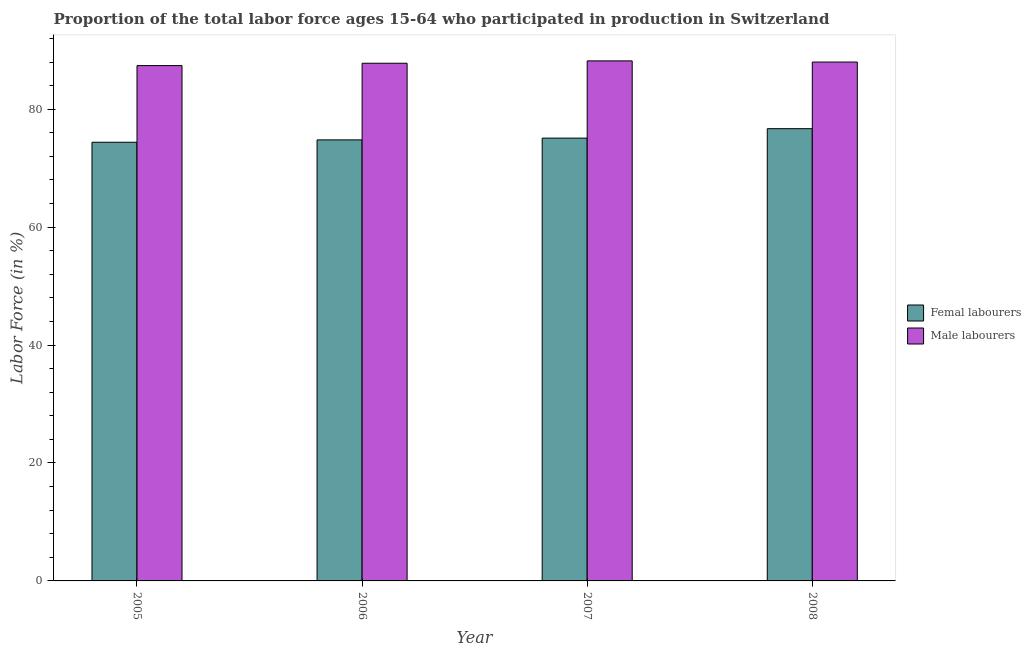How many bars are there on the 2nd tick from the right?
Provide a short and direct response. 2. What is the percentage of female labor force in 2005?
Provide a short and direct response. 74.4. Across all years, what is the maximum percentage of female labor force?
Keep it short and to the point. 76.7. Across all years, what is the minimum percentage of male labour force?
Provide a short and direct response. 87.4. In which year was the percentage of male labour force minimum?
Make the answer very short. 2005. What is the total percentage of female labor force in the graph?
Your answer should be very brief. 301. What is the difference between the percentage of female labor force in 2005 and that in 2007?
Provide a succinct answer. -0.7. What is the difference between the percentage of female labor force in 2005 and the percentage of male labour force in 2007?
Provide a succinct answer. -0.7. What is the average percentage of female labor force per year?
Keep it short and to the point. 75.25. In how many years, is the percentage of female labor force greater than 76 %?
Offer a terse response. 1. What is the ratio of the percentage of female labor force in 2007 to that in 2008?
Your answer should be compact. 0.98. What is the difference between the highest and the second highest percentage of male labour force?
Your answer should be compact. 0.2. What is the difference between the highest and the lowest percentage of male labour force?
Offer a terse response. 0.8. In how many years, is the percentage of male labour force greater than the average percentage of male labour force taken over all years?
Provide a short and direct response. 2. What does the 2nd bar from the left in 2005 represents?
Offer a very short reply. Male labourers. What does the 1st bar from the right in 2006 represents?
Offer a terse response. Male labourers. How many bars are there?
Your answer should be compact. 8. What is the difference between two consecutive major ticks on the Y-axis?
Give a very brief answer. 20. How many legend labels are there?
Provide a succinct answer. 2. What is the title of the graph?
Make the answer very short. Proportion of the total labor force ages 15-64 who participated in production in Switzerland. Does "By country of origin" appear as one of the legend labels in the graph?
Make the answer very short. No. What is the label or title of the X-axis?
Provide a short and direct response. Year. What is the label or title of the Y-axis?
Give a very brief answer. Labor Force (in %). What is the Labor Force (in %) of Femal labourers in 2005?
Give a very brief answer. 74.4. What is the Labor Force (in %) of Male labourers in 2005?
Offer a very short reply. 87.4. What is the Labor Force (in %) in Femal labourers in 2006?
Give a very brief answer. 74.8. What is the Labor Force (in %) in Male labourers in 2006?
Provide a short and direct response. 87.8. What is the Labor Force (in %) of Femal labourers in 2007?
Your answer should be compact. 75.1. What is the Labor Force (in %) in Male labourers in 2007?
Offer a very short reply. 88.2. What is the Labor Force (in %) of Femal labourers in 2008?
Ensure brevity in your answer.  76.7. What is the Labor Force (in %) of Male labourers in 2008?
Ensure brevity in your answer.  88. Across all years, what is the maximum Labor Force (in %) in Femal labourers?
Your response must be concise. 76.7. Across all years, what is the maximum Labor Force (in %) of Male labourers?
Your answer should be compact. 88.2. Across all years, what is the minimum Labor Force (in %) in Femal labourers?
Keep it short and to the point. 74.4. Across all years, what is the minimum Labor Force (in %) of Male labourers?
Ensure brevity in your answer.  87.4. What is the total Labor Force (in %) in Femal labourers in the graph?
Offer a very short reply. 301. What is the total Labor Force (in %) in Male labourers in the graph?
Offer a very short reply. 351.4. What is the difference between the Labor Force (in %) of Femal labourers in 2005 and that in 2007?
Provide a succinct answer. -0.7. What is the difference between the Labor Force (in %) in Male labourers in 2005 and that in 2007?
Your answer should be compact. -0.8. What is the difference between the Labor Force (in %) of Femal labourers in 2005 and that in 2008?
Offer a terse response. -2.3. What is the difference between the Labor Force (in %) in Femal labourers in 2006 and that in 2007?
Keep it short and to the point. -0.3. What is the difference between the Labor Force (in %) in Male labourers in 2006 and that in 2007?
Give a very brief answer. -0.4. What is the difference between the Labor Force (in %) in Male labourers in 2006 and that in 2008?
Your answer should be very brief. -0.2. What is the difference between the Labor Force (in %) of Femal labourers in 2007 and that in 2008?
Offer a terse response. -1.6. What is the difference between the Labor Force (in %) in Male labourers in 2007 and that in 2008?
Give a very brief answer. 0.2. What is the difference between the Labor Force (in %) of Femal labourers in 2005 and the Labor Force (in %) of Male labourers in 2006?
Your answer should be compact. -13.4. What is the difference between the Labor Force (in %) in Femal labourers in 2005 and the Labor Force (in %) in Male labourers in 2008?
Keep it short and to the point. -13.6. What is the difference between the Labor Force (in %) in Femal labourers in 2006 and the Labor Force (in %) in Male labourers in 2008?
Your answer should be compact. -13.2. What is the average Labor Force (in %) of Femal labourers per year?
Give a very brief answer. 75.25. What is the average Labor Force (in %) of Male labourers per year?
Offer a very short reply. 87.85. What is the ratio of the Labor Force (in %) of Femal labourers in 2005 to that in 2006?
Keep it short and to the point. 0.99. What is the ratio of the Labor Force (in %) in Femal labourers in 2005 to that in 2007?
Give a very brief answer. 0.99. What is the ratio of the Labor Force (in %) in Male labourers in 2005 to that in 2007?
Your response must be concise. 0.99. What is the ratio of the Labor Force (in %) in Male labourers in 2005 to that in 2008?
Give a very brief answer. 0.99. What is the ratio of the Labor Force (in %) of Femal labourers in 2006 to that in 2007?
Ensure brevity in your answer.  1. What is the ratio of the Labor Force (in %) in Femal labourers in 2006 to that in 2008?
Keep it short and to the point. 0.98. What is the ratio of the Labor Force (in %) of Femal labourers in 2007 to that in 2008?
Provide a short and direct response. 0.98. What is the difference between the highest and the lowest Labor Force (in %) of Femal labourers?
Ensure brevity in your answer.  2.3. 